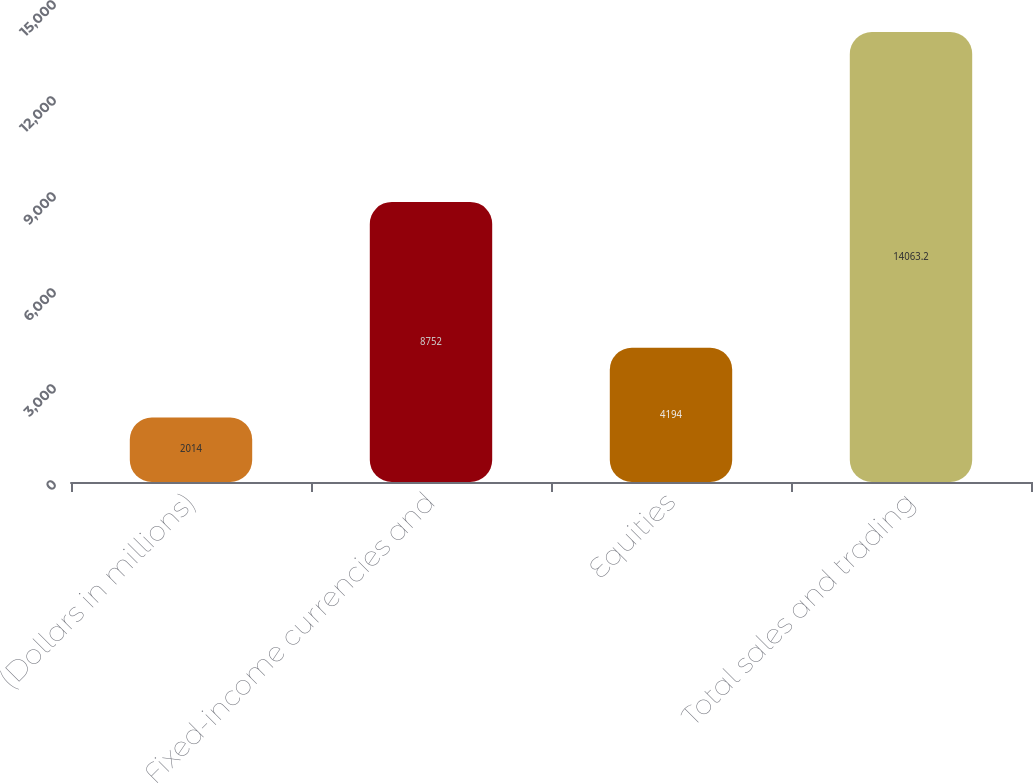Convert chart to OTSL. <chart><loc_0><loc_0><loc_500><loc_500><bar_chart><fcel>(Dollars in millions)<fcel>Fixed-income currencies and<fcel>Equities<fcel>Total sales and trading<nl><fcel>2014<fcel>8752<fcel>4194<fcel>14063.2<nl></chart> 